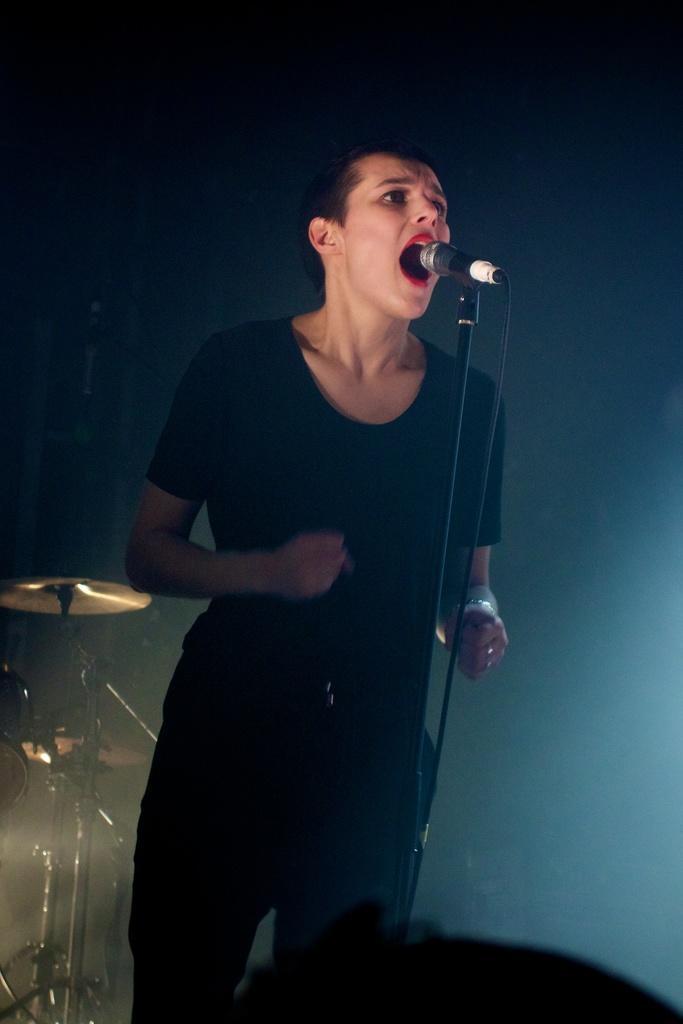Please provide a concise description of this image. In this picture I can see a woman standing and singing with the help of a microphone and I can see drums on the left side of the picture and looks like a dark color background. 